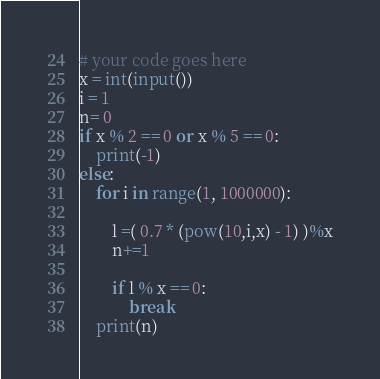Convert code to text. <code><loc_0><loc_0><loc_500><loc_500><_Python_># your code goes here
x = int(input())
i = 1
n= 0
if x % 2 == 0 or x % 5 == 0:
    print(-1)
else:
    for i in range(1, 1000000):

        l =( 0.7 * (pow(10,i,x) - 1) )%x
        n+=1
        
        if l % x == 0:
            break
    print(n)
</code> 